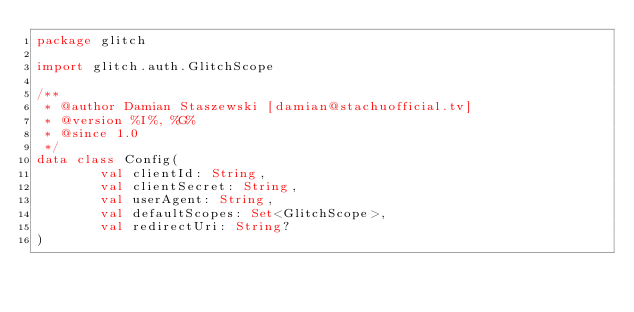<code> <loc_0><loc_0><loc_500><loc_500><_Kotlin_>package glitch

import glitch.auth.GlitchScope

/**
 * @author Damian Staszewski [damian@stachuofficial.tv]
 * @version %I%, %G%
 * @since 1.0
 */
data class Config(
        val clientId: String,
        val clientSecret: String,
        val userAgent: String,
        val defaultScopes: Set<GlitchScope>,
        val redirectUri: String?
)
</code> 